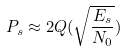<formula> <loc_0><loc_0><loc_500><loc_500>P _ { s } \approx 2 Q ( \sqrt { \frac { E _ { s } } { N _ { 0 } } } )</formula> 